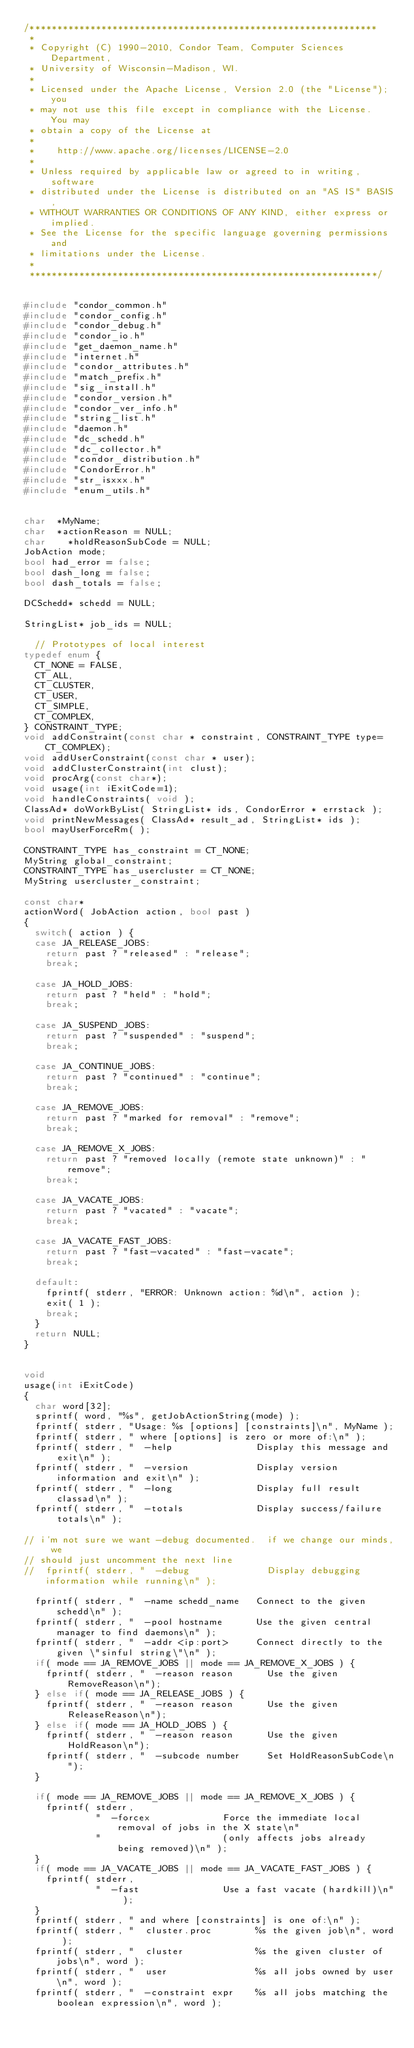Convert code to text. <code><loc_0><loc_0><loc_500><loc_500><_C++_>/***************************************************************
 *
 * Copyright (C) 1990-2010, Condor Team, Computer Sciences Department,
 * University of Wisconsin-Madison, WI.
 * 
 * Licensed under the Apache License, Version 2.0 (the "License"); you
 * may not use this file except in compliance with the License.  You may
 * obtain a copy of the License at
 * 
 *    http://www.apache.org/licenses/LICENSE-2.0
 * 
 * Unless required by applicable law or agreed to in writing, software
 * distributed under the License is distributed on an "AS IS" BASIS,
 * WITHOUT WARRANTIES OR CONDITIONS OF ANY KIND, either express or implied.
 * See the License for the specific language governing permissions and
 * limitations under the License.
 *
 ***************************************************************/


#include "condor_common.h"
#include "condor_config.h"
#include "condor_debug.h"
#include "condor_io.h"
#include "get_daemon_name.h"
#include "internet.h"
#include "condor_attributes.h"
#include "match_prefix.h"
#include "sig_install.h"
#include "condor_version.h"
#include "condor_ver_info.h"
#include "string_list.h"
#include "daemon.h"
#include "dc_schedd.h"
#include "dc_collector.h"
#include "condor_distribution.h"
#include "CondorError.h"
#include "str_isxxx.h"
#include "enum_utils.h"


char	*MyName;
char 	*actionReason = NULL;
char    *holdReasonSubCode = NULL;
JobAction mode;
bool had_error = false;
bool dash_long = false;
bool dash_totals = false;

DCSchedd* schedd = NULL;

StringList* job_ids = NULL;

	// Prototypes of local interest
typedef enum {
	CT_NONE = FALSE,
	CT_ALL,
	CT_CLUSTER,
	CT_USER,
	CT_SIMPLE,
	CT_COMPLEX,
} CONSTRAINT_TYPE;
void addConstraint(const char * constraint, CONSTRAINT_TYPE type=CT_COMPLEX);
void addUserConstraint(const char * user);
void addClusterConstraint(int clust);
void procArg(const char*);
void usage(int iExitCode=1);
void handleConstraints( void );
ClassAd* doWorkByList( StringList* ids, CondorError * errstack );
void printNewMessages( ClassAd* result_ad, StringList* ids );
bool mayUserForceRm( );

CONSTRAINT_TYPE has_constraint = CT_NONE;
MyString global_constraint;
CONSTRAINT_TYPE has_usercluster = CT_NONE;
MyString usercluster_constraint;

const char* 
actionWord( JobAction action, bool past )
{
	switch( action ) {
	case JA_RELEASE_JOBS:
		return past ? "released" : "release";
		break;

	case JA_HOLD_JOBS:
		return past ? "held" : "hold";
		break;
	
	case JA_SUSPEND_JOBS:
		return past ? "suspended" : "suspend";
		break;
		
	case JA_CONTINUE_JOBS:
		return past ? "continued" : "continue";
		break;

	case JA_REMOVE_JOBS:
		return past ? "marked for removal" : "remove";
		break;

	case JA_REMOVE_X_JOBS:
		return past ? "removed locally (remote state unknown)" : "remove";
		break;

	case JA_VACATE_JOBS:
		return past ? "vacated" : "vacate";
		break;

	case JA_VACATE_FAST_JOBS:
		return past ? "fast-vacated" : "fast-vacate";
		break;

	default:
		fprintf( stderr, "ERROR: Unknown action: %d\n", action );
		exit( 1 );
		break;
	}
	return NULL;
}


void
usage(int iExitCode)
{
	char word[32];
	sprintf( word, "%s", getJobActionString(mode) );
	fprintf( stderr, "Usage: %s [options] [constraints]\n", MyName );
	fprintf( stderr, " where [options] is zero or more of:\n" );
	fprintf( stderr, "  -help               Display this message and exit\n" );
	fprintf( stderr, "  -version            Display version information and exit\n" );
	fprintf( stderr, "  -long               Display full result classad\n" );
	fprintf( stderr, "  -totals             Display success/failure totals\n" );

// i'm not sure we want -debug documented.  if we change our minds, we
// should just uncomment the next line
//	fprintf( stderr, "  -debug              Display debugging information while running\n" );

	fprintf( stderr, "  -name schedd_name   Connect to the given schedd\n" );
	fprintf( stderr, "  -pool hostname      Use the given central manager to find daemons\n" );
	fprintf( stderr, "  -addr <ip:port>     Connect directly to the given \"sinful string\"\n" );
	if( mode == JA_REMOVE_JOBS || mode == JA_REMOVE_X_JOBS ) {
		fprintf( stderr, "  -reason reason      Use the given RemoveReason\n");
	} else if( mode == JA_RELEASE_JOBS ) {
		fprintf( stderr, "  -reason reason      Use the given ReleaseReason\n");
	} else if( mode == JA_HOLD_JOBS ) {
		fprintf( stderr, "  -reason reason      Use the given HoldReason\n");
		fprintf( stderr, "  -subcode number     Set HoldReasonSubCode\n");
	}

	if( mode == JA_REMOVE_JOBS || mode == JA_REMOVE_X_JOBS ) {
		fprintf( stderr,
				     "  -forcex             Force the immediate local removal of jobs in the X state\n"
		         "                      (only affects jobs already being removed)\n" );
	}
	if( mode == JA_VACATE_JOBS || mode == JA_VACATE_FAST_JOBS ) {
		fprintf( stderr,
				     "  -fast               Use a fast vacate (hardkill)\n" );
	}
	fprintf( stderr, " and where [constraints] is one of:\n" );
	fprintf( stderr, "  cluster.proc        %s the given job\n", word );
	fprintf( stderr, "  cluster             %s the given cluster of jobs\n", word );
	fprintf( stderr, "  user                %s all jobs owned by user\n", word );
	fprintf( stderr, "  -constraint expr    %s all jobs matching the boolean expression\n", word );</code> 